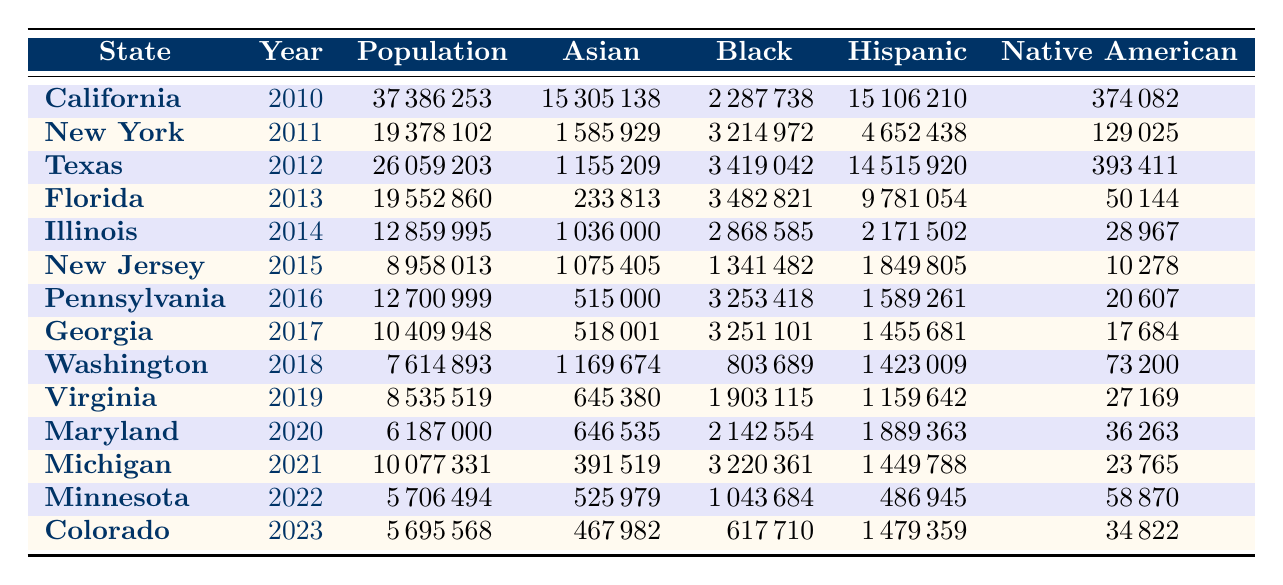What was the total population in New York in 2011? Looking at the table, the row for New York in 2011 shows that the total population was 19378102.
Answer: 19378102 Which state had the highest Hispanic population in 2012? By examining the table, Texas had the highest Hispanic population in 2012 at 14515920.
Answer: Texas What is the difference in the Black population between 2014 (Illinois) and 2016 (Pennsylvania)? The Black population in Illinois in 2014 was 2868585, while in Pennsylvania in 2016 it was 3253418. The difference is 3253418 - 2868585 = 383833.
Answer: 383833 In which year did California have the highest Asian population? Looking at the table, California's Asian population was highest in 2010 at 15305138 and no other year had a higher value in that state.
Answer: 2010 What percentage of the total population in Florida in 2013 was Black? The total population in Florida in 2013 was 19552860, and the Black population was 3482821. To find the percentage, we calculate (3482821 / 19552860) * 100, which equals about 17.8%.
Answer: 17.8% Did the total population of Minnesota increase or decrease from 2022 to 2023? In 2022, the population of Minnesota was 5706494, and in 2023 it was also 5695568. This shows a decrease of 126.
Answer: Decrease What was the average Hispanic population for the states listed from 2010 to 2023? To find the average, sum up all the Hispanic populations from the years (15106210 + 4652438 + 14515920 + 9781054 + 2171502 + 1849805 + 1589261 + 1455681 + 1423009 + 1159642 + 1889363 + 1449788 + 486945 + 1479359 = 66162867) and divide by 14 (the number of years/entries), which gives 66162867 / 14 = 4720004.79.
Answer: 4720004.79 How many states had a Native American population greater than 30000 in 2015 and 2020? In 2015, New Jersey had a Native American population of 10278, which is less. In 2020, Maryland had 36263. Therefore, only Maryland had more than 30000 in 2020. The answer to both years is 0 for 2015 and later one for 2020.
Answer: 0 in 2015, 1 in 2020 What is the total Asian population across all states in 2019? From the table, the Asian populations for 2019 from the different states sum up to (645380). Therefore, the total Asian population in Virginia in 2019 is 645380.
Answer: 645380 Was the Asian population higher in Texas in 2012 compared to Georgia in 2017? Texas in 2012 had an Asian population of 1155209 while Georgia in 2017 had 518001, therefore the Asian population in Texas was higher.
Answer: Yes 